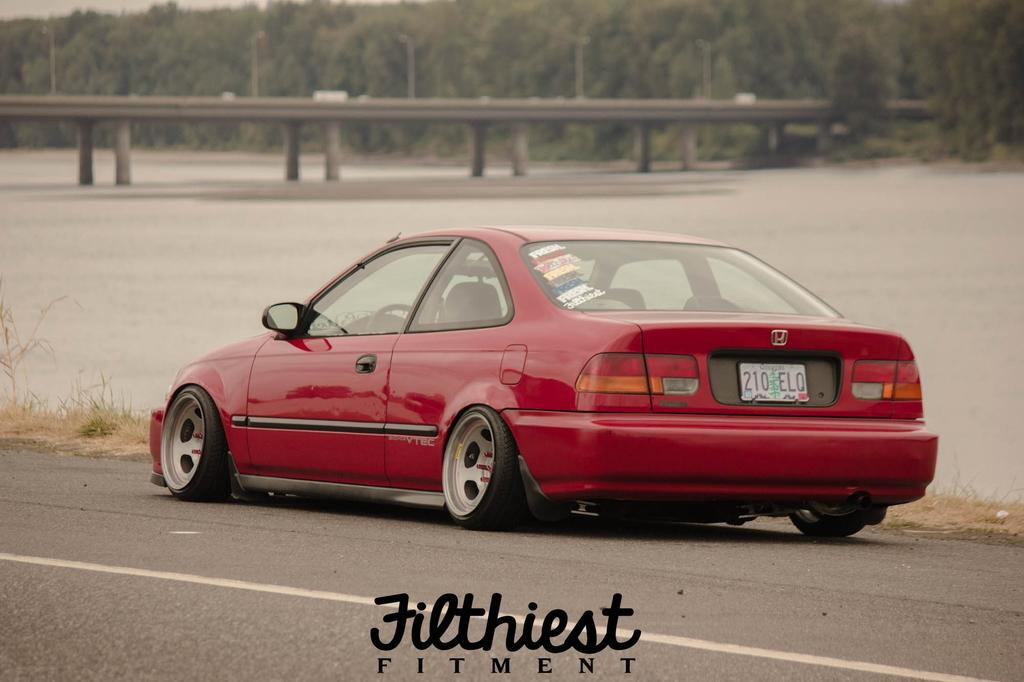What is the main subject of the image? There is a car on the road in the image. What type of vegetation can be seen in the image? There is grass visible in the image. What type of structure is present in the image? There is a bridge in the image. What objects are present in the image that are not part of the car or the bridge? There are poles and some text visible in the image. What can be seen in the background of the image? There are trees in the background of the image. How many brothers are depicted in the image? There are no brothers present in the image. What type of gold object can be seen in the image? There is no gold object present in the image. 